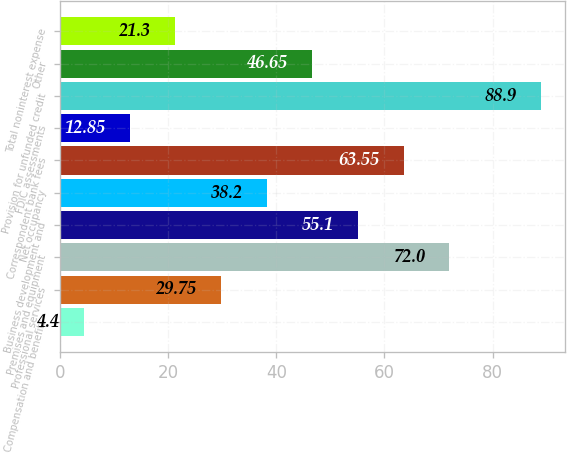Convert chart to OTSL. <chart><loc_0><loc_0><loc_500><loc_500><bar_chart><fcel>Compensation and benefits<fcel>Professional services<fcel>Premises and equipment<fcel>Business development and<fcel>Net occupancy<fcel>Correspondent bank fees<fcel>FDIC assessments<fcel>Provision for unfunded credit<fcel>Other<fcel>Total noninterest expense<nl><fcel>4.4<fcel>29.75<fcel>72<fcel>55.1<fcel>38.2<fcel>63.55<fcel>12.85<fcel>88.9<fcel>46.65<fcel>21.3<nl></chart> 